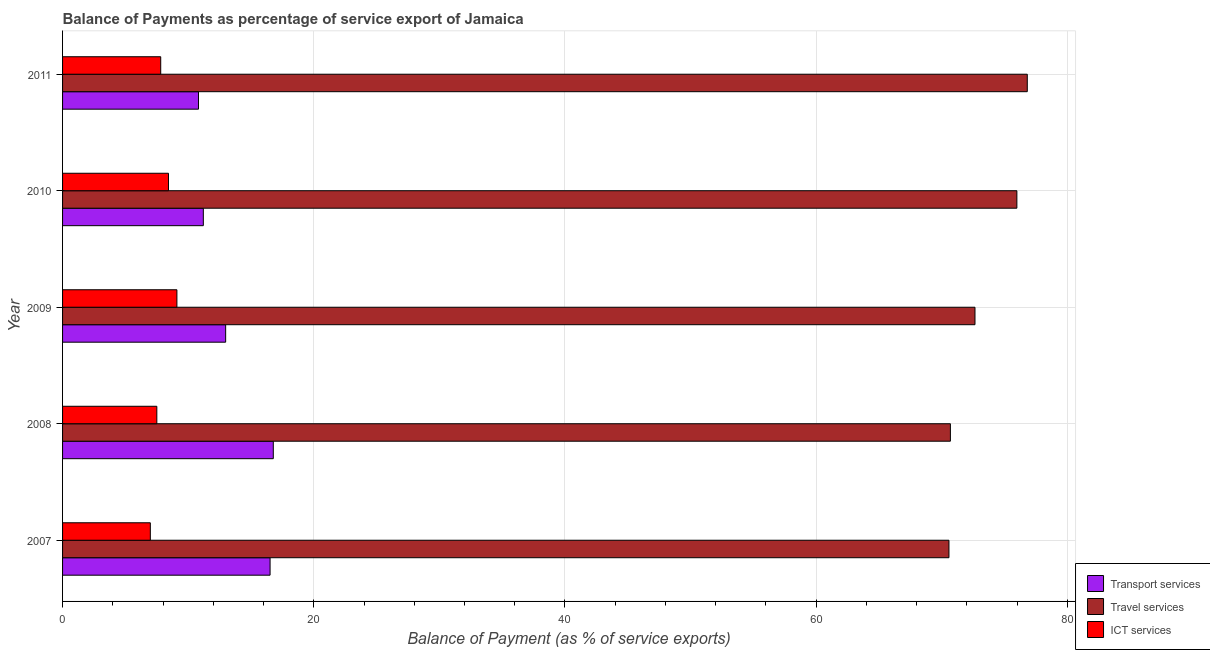How many different coloured bars are there?
Make the answer very short. 3. How many bars are there on the 1st tick from the top?
Offer a very short reply. 3. What is the balance of payment of ict services in 2009?
Your response must be concise. 9.1. Across all years, what is the maximum balance of payment of travel services?
Give a very brief answer. 76.81. Across all years, what is the minimum balance of payment of ict services?
Provide a succinct answer. 6.99. In which year was the balance of payment of travel services maximum?
Offer a very short reply. 2011. In which year was the balance of payment of ict services minimum?
Your answer should be compact. 2007. What is the total balance of payment of ict services in the graph?
Ensure brevity in your answer.  39.84. What is the difference between the balance of payment of ict services in 2007 and that in 2009?
Make the answer very short. -2.12. What is the difference between the balance of payment of transport services in 2007 and the balance of payment of ict services in 2011?
Offer a terse response. 8.71. What is the average balance of payment of ict services per year?
Keep it short and to the point. 7.97. In the year 2008, what is the difference between the balance of payment of ict services and balance of payment of travel services?
Make the answer very short. -63.18. What is the ratio of the balance of payment of transport services in 2008 to that in 2009?
Your answer should be compact. 1.29. Is the balance of payment of ict services in 2010 less than that in 2011?
Provide a succinct answer. No. Is the difference between the balance of payment of travel services in 2009 and 2010 greater than the difference between the balance of payment of ict services in 2009 and 2010?
Ensure brevity in your answer.  No. What is the difference between the highest and the second highest balance of payment of travel services?
Offer a very short reply. 0.83. What is the difference between the highest and the lowest balance of payment of travel services?
Your response must be concise. 6.24. Is the sum of the balance of payment of ict services in 2009 and 2011 greater than the maximum balance of payment of transport services across all years?
Offer a very short reply. Yes. What does the 2nd bar from the top in 2011 represents?
Your response must be concise. Travel services. What does the 3rd bar from the bottom in 2009 represents?
Keep it short and to the point. ICT services. Is it the case that in every year, the sum of the balance of payment of transport services and balance of payment of travel services is greater than the balance of payment of ict services?
Keep it short and to the point. Yes. What is the difference between two consecutive major ticks on the X-axis?
Your answer should be very brief. 20. Are the values on the major ticks of X-axis written in scientific E-notation?
Your response must be concise. No. Does the graph contain any zero values?
Ensure brevity in your answer.  No. Where does the legend appear in the graph?
Offer a terse response. Bottom right. How are the legend labels stacked?
Your answer should be compact. Vertical. What is the title of the graph?
Offer a very short reply. Balance of Payments as percentage of service export of Jamaica. Does "Resident buildings and public services" appear as one of the legend labels in the graph?
Your answer should be very brief. No. What is the label or title of the X-axis?
Make the answer very short. Balance of Payment (as % of service exports). What is the label or title of the Y-axis?
Your answer should be compact. Year. What is the Balance of Payment (as % of service exports) in Transport services in 2007?
Offer a terse response. 16.52. What is the Balance of Payment (as % of service exports) in Travel services in 2007?
Your answer should be very brief. 70.57. What is the Balance of Payment (as % of service exports) in ICT services in 2007?
Provide a short and direct response. 6.99. What is the Balance of Payment (as % of service exports) of Transport services in 2008?
Give a very brief answer. 16.78. What is the Balance of Payment (as % of service exports) in Travel services in 2008?
Give a very brief answer. 70.69. What is the Balance of Payment (as % of service exports) of ICT services in 2008?
Offer a very short reply. 7.5. What is the Balance of Payment (as % of service exports) of Transport services in 2009?
Your response must be concise. 12.98. What is the Balance of Payment (as % of service exports) of Travel services in 2009?
Your response must be concise. 72.64. What is the Balance of Payment (as % of service exports) of ICT services in 2009?
Your response must be concise. 9.1. What is the Balance of Payment (as % of service exports) in Transport services in 2010?
Provide a short and direct response. 11.21. What is the Balance of Payment (as % of service exports) in Travel services in 2010?
Provide a succinct answer. 75.98. What is the Balance of Payment (as % of service exports) of ICT services in 2010?
Your answer should be compact. 8.43. What is the Balance of Payment (as % of service exports) in Transport services in 2011?
Give a very brief answer. 10.82. What is the Balance of Payment (as % of service exports) of Travel services in 2011?
Offer a terse response. 76.81. What is the Balance of Payment (as % of service exports) of ICT services in 2011?
Provide a short and direct response. 7.81. Across all years, what is the maximum Balance of Payment (as % of service exports) of Transport services?
Keep it short and to the point. 16.78. Across all years, what is the maximum Balance of Payment (as % of service exports) of Travel services?
Ensure brevity in your answer.  76.81. Across all years, what is the maximum Balance of Payment (as % of service exports) in ICT services?
Give a very brief answer. 9.1. Across all years, what is the minimum Balance of Payment (as % of service exports) of Transport services?
Your response must be concise. 10.82. Across all years, what is the minimum Balance of Payment (as % of service exports) of Travel services?
Your answer should be compact. 70.57. Across all years, what is the minimum Balance of Payment (as % of service exports) of ICT services?
Provide a succinct answer. 6.99. What is the total Balance of Payment (as % of service exports) in Transport services in the graph?
Offer a very short reply. 68.31. What is the total Balance of Payment (as % of service exports) of Travel services in the graph?
Your answer should be very brief. 366.69. What is the total Balance of Payment (as % of service exports) of ICT services in the graph?
Your answer should be compact. 39.84. What is the difference between the Balance of Payment (as % of service exports) of Transport services in 2007 and that in 2008?
Your response must be concise. -0.26. What is the difference between the Balance of Payment (as % of service exports) of Travel services in 2007 and that in 2008?
Give a very brief answer. -0.12. What is the difference between the Balance of Payment (as % of service exports) of ICT services in 2007 and that in 2008?
Keep it short and to the point. -0.52. What is the difference between the Balance of Payment (as % of service exports) of Transport services in 2007 and that in 2009?
Make the answer very short. 3.54. What is the difference between the Balance of Payment (as % of service exports) in Travel services in 2007 and that in 2009?
Your answer should be very brief. -2.07. What is the difference between the Balance of Payment (as % of service exports) in ICT services in 2007 and that in 2009?
Offer a very short reply. -2.12. What is the difference between the Balance of Payment (as % of service exports) in Transport services in 2007 and that in 2010?
Provide a short and direct response. 5.31. What is the difference between the Balance of Payment (as % of service exports) of Travel services in 2007 and that in 2010?
Your response must be concise. -5.41. What is the difference between the Balance of Payment (as % of service exports) of ICT services in 2007 and that in 2010?
Your answer should be very brief. -1.45. What is the difference between the Balance of Payment (as % of service exports) in Transport services in 2007 and that in 2011?
Ensure brevity in your answer.  5.7. What is the difference between the Balance of Payment (as % of service exports) of Travel services in 2007 and that in 2011?
Your answer should be very brief. -6.24. What is the difference between the Balance of Payment (as % of service exports) in ICT services in 2007 and that in 2011?
Make the answer very short. -0.83. What is the difference between the Balance of Payment (as % of service exports) of Transport services in 2008 and that in 2009?
Your answer should be very brief. 3.79. What is the difference between the Balance of Payment (as % of service exports) in Travel services in 2008 and that in 2009?
Keep it short and to the point. -1.96. What is the difference between the Balance of Payment (as % of service exports) of ICT services in 2008 and that in 2009?
Keep it short and to the point. -1.6. What is the difference between the Balance of Payment (as % of service exports) in Transport services in 2008 and that in 2010?
Provide a short and direct response. 5.57. What is the difference between the Balance of Payment (as % of service exports) of Travel services in 2008 and that in 2010?
Offer a terse response. -5.29. What is the difference between the Balance of Payment (as % of service exports) in ICT services in 2008 and that in 2010?
Provide a succinct answer. -0.93. What is the difference between the Balance of Payment (as % of service exports) of Transport services in 2008 and that in 2011?
Make the answer very short. 5.96. What is the difference between the Balance of Payment (as % of service exports) in Travel services in 2008 and that in 2011?
Your response must be concise. -6.12. What is the difference between the Balance of Payment (as % of service exports) in ICT services in 2008 and that in 2011?
Your answer should be very brief. -0.31. What is the difference between the Balance of Payment (as % of service exports) in Transport services in 2009 and that in 2010?
Keep it short and to the point. 1.78. What is the difference between the Balance of Payment (as % of service exports) in Travel services in 2009 and that in 2010?
Provide a short and direct response. -3.34. What is the difference between the Balance of Payment (as % of service exports) in ICT services in 2009 and that in 2010?
Give a very brief answer. 0.67. What is the difference between the Balance of Payment (as % of service exports) in Transport services in 2009 and that in 2011?
Make the answer very short. 2.16. What is the difference between the Balance of Payment (as % of service exports) of Travel services in 2009 and that in 2011?
Your response must be concise. -4.16. What is the difference between the Balance of Payment (as % of service exports) of ICT services in 2009 and that in 2011?
Make the answer very short. 1.29. What is the difference between the Balance of Payment (as % of service exports) in Transport services in 2010 and that in 2011?
Provide a short and direct response. 0.39. What is the difference between the Balance of Payment (as % of service exports) in Travel services in 2010 and that in 2011?
Offer a very short reply. -0.83. What is the difference between the Balance of Payment (as % of service exports) in ICT services in 2010 and that in 2011?
Offer a very short reply. 0.62. What is the difference between the Balance of Payment (as % of service exports) of Transport services in 2007 and the Balance of Payment (as % of service exports) of Travel services in 2008?
Offer a terse response. -54.16. What is the difference between the Balance of Payment (as % of service exports) in Transport services in 2007 and the Balance of Payment (as % of service exports) in ICT services in 2008?
Your answer should be very brief. 9.02. What is the difference between the Balance of Payment (as % of service exports) in Travel services in 2007 and the Balance of Payment (as % of service exports) in ICT services in 2008?
Provide a short and direct response. 63.07. What is the difference between the Balance of Payment (as % of service exports) of Transport services in 2007 and the Balance of Payment (as % of service exports) of Travel services in 2009?
Your response must be concise. -56.12. What is the difference between the Balance of Payment (as % of service exports) in Transport services in 2007 and the Balance of Payment (as % of service exports) in ICT services in 2009?
Provide a short and direct response. 7.42. What is the difference between the Balance of Payment (as % of service exports) of Travel services in 2007 and the Balance of Payment (as % of service exports) of ICT services in 2009?
Your answer should be very brief. 61.47. What is the difference between the Balance of Payment (as % of service exports) of Transport services in 2007 and the Balance of Payment (as % of service exports) of Travel services in 2010?
Give a very brief answer. -59.46. What is the difference between the Balance of Payment (as % of service exports) in Transport services in 2007 and the Balance of Payment (as % of service exports) in ICT services in 2010?
Your answer should be very brief. 8.09. What is the difference between the Balance of Payment (as % of service exports) of Travel services in 2007 and the Balance of Payment (as % of service exports) of ICT services in 2010?
Your response must be concise. 62.14. What is the difference between the Balance of Payment (as % of service exports) of Transport services in 2007 and the Balance of Payment (as % of service exports) of Travel services in 2011?
Provide a short and direct response. -60.29. What is the difference between the Balance of Payment (as % of service exports) of Transport services in 2007 and the Balance of Payment (as % of service exports) of ICT services in 2011?
Keep it short and to the point. 8.71. What is the difference between the Balance of Payment (as % of service exports) in Travel services in 2007 and the Balance of Payment (as % of service exports) in ICT services in 2011?
Your response must be concise. 62.76. What is the difference between the Balance of Payment (as % of service exports) of Transport services in 2008 and the Balance of Payment (as % of service exports) of Travel services in 2009?
Make the answer very short. -55.87. What is the difference between the Balance of Payment (as % of service exports) of Transport services in 2008 and the Balance of Payment (as % of service exports) of ICT services in 2009?
Your answer should be very brief. 7.67. What is the difference between the Balance of Payment (as % of service exports) in Travel services in 2008 and the Balance of Payment (as % of service exports) in ICT services in 2009?
Offer a terse response. 61.58. What is the difference between the Balance of Payment (as % of service exports) in Transport services in 2008 and the Balance of Payment (as % of service exports) in Travel services in 2010?
Offer a terse response. -59.2. What is the difference between the Balance of Payment (as % of service exports) in Transport services in 2008 and the Balance of Payment (as % of service exports) in ICT services in 2010?
Offer a terse response. 8.34. What is the difference between the Balance of Payment (as % of service exports) in Travel services in 2008 and the Balance of Payment (as % of service exports) in ICT services in 2010?
Provide a short and direct response. 62.25. What is the difference between the Balance of Payment (as % of service exports) in Transport services in 2008 and the Balance of Payment (as % of service exports) in Travel services in 2011?
Your response must be concise. -60.03. What is the difference between the Balance of Payment (as % of service exports) of Transport services in 2008 and the Balance of Payment (as % of service exports) of ICT services in 2011?
Make the answer very short. 8.96. What is the difference between the Balance of Payment (as % of service exports) of Travel services in 2008 and the Balance of Payment (as % of service exports) of ICT services in 2011?
Provide a short and direct response. 62.87. What is the difference between the Balance of Payment (as % of service exports) in Transport services in 2009 and the Balance of Payment (as % of service exports) in Travel services in 2010?
Provide a short and direct response. -62.99. What is the difference between the Balance of Payment (as % of service exports) of Transport services in 2009 and the Balance of Payment (as % of service exports) of ICT services in 2010?
Make the answer very short. 4.55. What is the difference between the Balance of Payment (as % of service exports) of Travel services in 2009 and the Balance of Payment (as % of service exports) of ICT services in 2010?
Offer a very short reply. 64.21. What is the difference between the Balance of Payment (as % of service exports) of Transport services in 2009 and the Balance of Payment (as % of service exports) of Travel services in 2011?
Provide a short and direct response. -63.82. What is the difference between the Balance of Payment (as % of service exports) in Transport services in 2009 and the Balance of Payment (as % of service exports) in ICT services in 2011?
Your answer should be compact. 5.17. What is the difference between the Balance of Payment (as % of service exports) in Travel services in 2009 and the Balance of Payment (as % of service exports) in ICT services in 2011?
Offer a terse response. 64.83. What is the difference between the Balance of Payment (as % of service exports) of Transport services in 2010 and the Balance of Payment (as % of service exports) of Travel services in 2011?
Make the answer very short. -65.6. What is the difference between the Balance of Payment (as % of service exports) of Transport services in 2010 and the Balance of Payment (as % of service exports) of ICT services in 2011?
Your response must be concise. 3.39. What is the difference between the Balance of Payment (as % of service exports) in Travel services in 2010 and the Balance of Payment (as % of service exports) in ICT services in 2011?
Make the answer very short. 68.16. What is the average Balance of Payment (as % of service exports) in Transport services per year?
Provide a succinct answer. 13.66. What is the average Balance of Payment (as % of service exports) of Travel services per year?
Ensure brevity in your answer.  73.34. What is the average Balance of Payment (as % of service exports) in ICT services per year?
Offer a terse response. 7.97. In the year 2007, what is the difference between the Balance of Payment (as % of service exports) of Transport services and Balance of Payment (as % of service exports) of Travel services?
Provide a succinct answer. -54.05. In the year 2007, what is the difference between the Balance of Payment (as % of service exports) in Transport services and Balance of Payment (as % of service exports) in ICT services?
Offer a very short reply. 9.53. In the year 2007, what is the difference between the Balance of Payment (as % of service exports) in Travel services and Balance of Payment (as % of service exports) in ICT services?
Your response must be concise. 63.58. In the year 2008, what is the difference between the Balance of Payment (as % of service exports) in Transport services and Balance of Payment (as % of service exports) in Travel services?
Offer a very short reply. -53.91. In the year 2008, what is the difference between the Balance of Payment (as % of service exports) of Transport services and Balance of Payment (as % of service exports) of ICT services?
Your response must be concise. 9.27. In the year 2008, what is the difference between the Balance of Payment (as % of service exports) of Travel services and Balance of Payment (as % of service exports) of ICT services?
Give a very brief answer. 63.18. In the year 2009, what is the difference between the Balance of Payment (as % of service exports) in Transport services and Balance of Payment (as % of service exports) in Travel services?
Offer a very short reply. -59.66. In the year 2009, what is the difference between the Balance of Payment (as % of service exports) in Transport services and Balance of Payment (as % of service exports) in ICT services?
Your response must be concise. 3.88. In the year 2009, what is the difference between the Balance of Payment (as % of service exports) of Travel services and Balance of Payment (as % of service exports) of ICT services?
Ensure brevity in your answer.  63.54. In the year 2010, what is the difference between the Balance of Payment (as % of service exports) in Transport services and Balance of Payment (as % of service exports) in Travel services?
Provide a short and direct response. -64.77. In the year 2010, what is the difference between the Balance of Payment (as % of service exports) in Transport services and Balance of Payment (as % of service exports) in ICT services?
Your answer should be very brief. 2.77. In the year 2010, what is the difference between the Balance of Payment (as % of service exports) of Travel services and Balance of Payment (as % of service exports) of ICT services?
Offer a very short reply. 67.55. In the year 2011, what is the difference between the Balance of Payment (as % of service exports) in Transport services and Balance of Payment (as % of service exports) in Travel services?
Offer a terse response. -65.99. In the year 2011, what is the difference between the Balance of Payment (as % of service exports) in Transport services and Balance of Payment (as % of service exports) in ICT services?
Your answer should be compact. 3.01. In the year 2011, what is the difference between the Balance of Payment (as % of service exports) in Travel services and Balance of Payment (as % of service exports) in ICT services?
Provide a short and direct response. 68.99. What is the ratio of the Balance of Payment (as % of service exports) in ICT services in 2007 to that in 2008?
Your answer should be very brief. 0.93. What is the ratio of the Balance of Payment (as % of service exports) in Transport services in 2007 to that in 2009?
Make the answer very short. 1.27. What is the ratio of the Balance of Payment (as % of service exports) in Travel services in 2007 to that in 2009?
Ensure brevity in your answer.  0.97. What is the ratio of the Balance of Payment (as % of service exports) of ICT services in 2007 to that in 2009?
Offer a very short reply. 0.77. What is the ratio of the Balance of Payment (as % of service exports) of Transport services in 2007 to that in 2010?
Your answer should be very brief. 1.47. What is the ratio of the Balance of Payment (as % of service exports) in Travel services in 2007 to that in 2010?
Provide a succinct answer. 0.93. What is the ratio of the Balance of Payment (as % of service exports) in ICT services in 2007 to that in 2010?
Your answer should be compact. 0.83. What is the ratio of the Balance of Payment (as % of service exports) of Transport services in 2007 to that in 2011?
Give a very brief answer. 1.53. What is the ratio of the Balance of Payment (as % of service exports) of Travel services in 2007 to that in 2011?
Provide a succinct answer. 0.92. What is the ratio of the Balance of Payment (as % of service exports) of ICT services in 2007 to that in 2011?
Your answer should be compact. 0.89. What is the ratio of the Balance of Payment (as % of service exports) in Transport services in 2008 to that in 2009?
Your answer should be compact. 1.29. What is the ratio of the Balance of Payment (as % of service exports) in Travel services in 2008 to that in 2009?
Your answer should be compact. 0.97. What is the ratio of the Balance of Payment (as % of service exports) in ICT services in 2008 to that in 2009?
Keep it short and to the point. 0.82. What is the ratio of the Balance of Payment (as % of service exports) of Transport services in 2008 to that in 2010?
Your answer should be compact. 1.5. What is the ratio of the Balance of Payment (as % of service exports) of Travel services in 2008 to that in 2010?
Give a very brief answer. 0.93. What is the ratio of the Balance of Payment (as % of service exports) in ICT services in 2008 to that in 2010?
Provide a succinct answer. 0.89. What is the ratio of the Balance of Payment (as % of service exports) of Transport services in 2008 to that in 2011?
Make the answer very short. 1.55. What is the ratio of the Balance of Payment (as % of service exports) in Travel services in 2008 to that in 2011?
Your response must be concise. 0.92. What is the ratio of the Balance of Payment (as % of service exports) of ICT services in 2008 to that in 2011?
Keep it short and to the point. 0.96. What is the ratio of the Balance of Payment (as % of service exports) of Transport services in 2009 to that in 2010?
Provide a succinct answer. 1.16. What is the ratio of the Balance of Payment (as % of service exports) in Travel services in 2009 to that in 2010?
Offer a very short reply. 0.96. What is the ratio of the Balance of Payment (as % of service exports) of ICT services in 2009 to that in 2010?
Offer a terse response. 1.08. What is the ratio of the Balance of Payment (as % of service exports) of Transport services in 2009 to that in 2011?
Offer a very short reply. 1.2. What is the ratio of the Balance of Payment (as % of service exports) of Travel services in 2009 to that in 2011?
Keep it short and to the point. 0.95. What is the ratio of the Balance of Payment (as % of service exports) of ICT services in 2009 to that in 2011?
Provide a short and direct response. 1.16. What is the ratio of the Balance of Payment (as % of service exports) of Transport services in 2010 to that in 2011?
Your answer should be very brief. 1.04. What is the ratio of the Balance of Payment (as % of service exports) of ICT services in 2010 to that in 2011?
Provide a short and direct response. 1.08. What is the difference between the highest and the second highest Balance of Payment (as % of service exports) in Transport services?
Provide a short and direct response. 0.26. What is the difference between the highest and the second highest Balance of Payment (as % of service exports) in Travel services?
Your answer should be compact. 0.83. What is the difference between the highest and the second highest Balance of Payment (as % of service exports) of ICT services?
Provide a short and direct response. 0.67. What is the difference between the highest and the lowest Balance of Payment (as % of service exports) of Transport services?
Offer a very short reply. 5.96. What is the difference between the highest and the lowest Balance of Payment (as % of service exports) in Travel services?
Ensure brevity in your answer.  6.24. What is the difference between the highest and the lowest Balance of Payment (as % of service exports) in ICT services?
Offer a terse response. 2.12. 